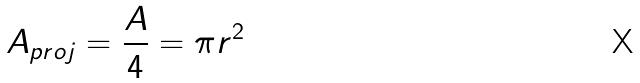Convert formula to latex. <formula><loc_0><loc_0><loc_500><loc_500>A _ { p r o j } = \frac { A } { 4 } = \pi r ^ { 2 }</formula> 